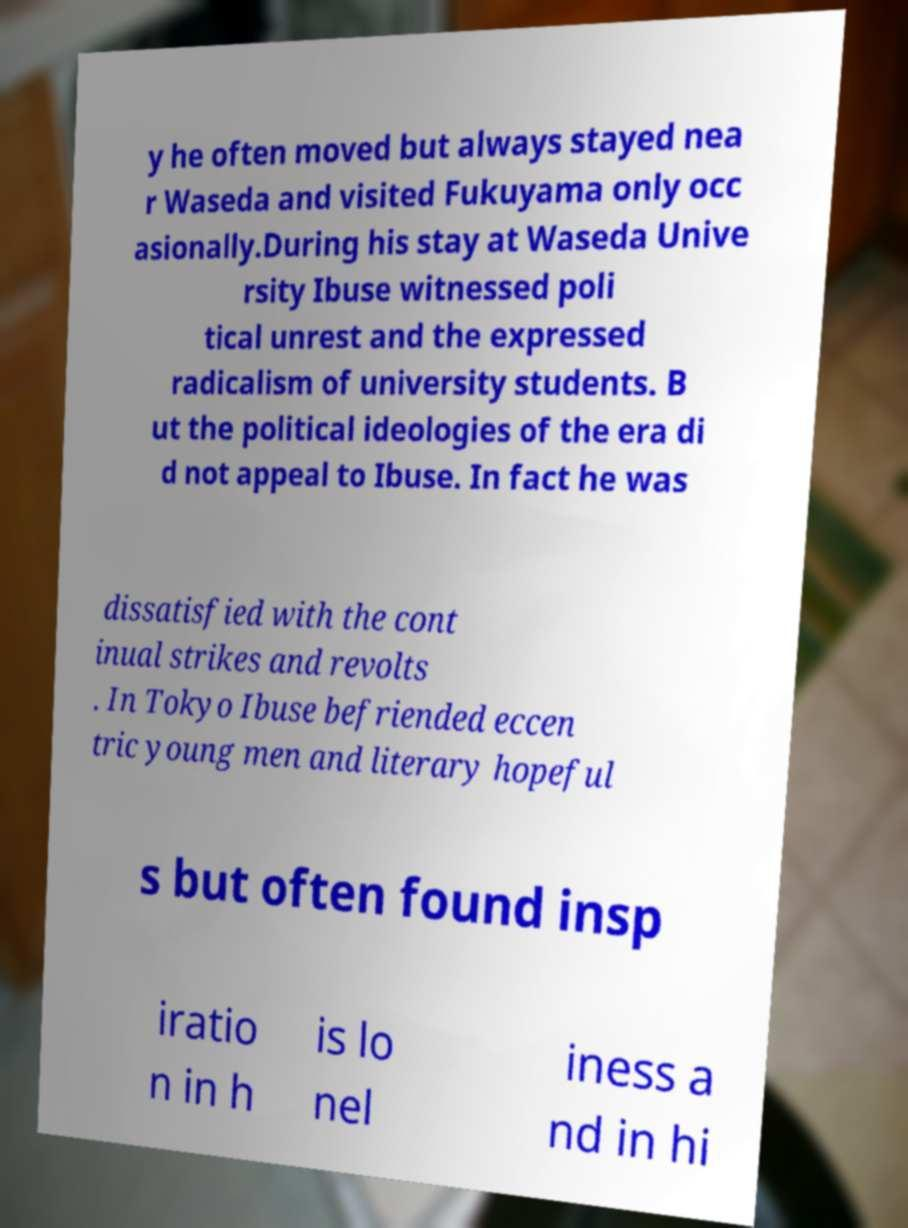Could you assist in decoding the text presented in this image and type it out clearly? y he often moved but always stayed nea r Waseda and visited Fukuyama only occ asionally.During his stay at Waseda Unive rsity Ibuse witnessed poli tical unrest and the expressed radicalism of university students. B ut the political ideologies of the era di d not appeal to Ibuse. In fact he was dissatisfied with the cont inual strikes and revolts . In Tokyo Ibuse befriended eccen tric young men and literary hopeful s but often found insp iratio n in h is lo nel iness a nd in hi 